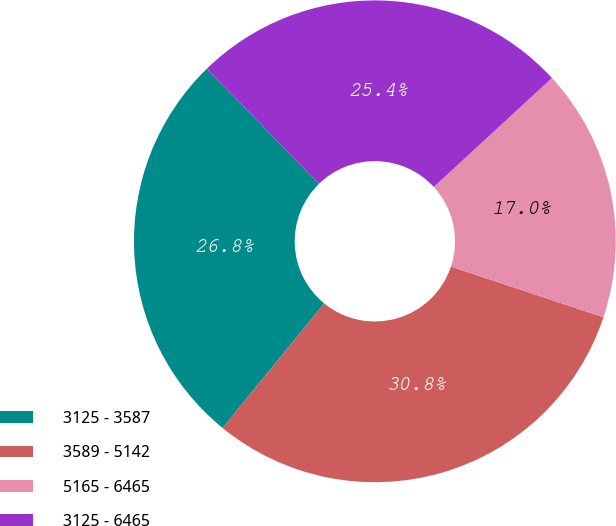<chart> <loc_0><loc_0><loc_500><loc_500><pie_chart><fcel>3125 - 3587<fcel>3589 - 5142<fcel>5165 - 6465<fcel>3125 - 6465<nl><fcel>26.82%<fcel>30.79%<fcel>16.96%<fcel>25.44%<nl></chart> 